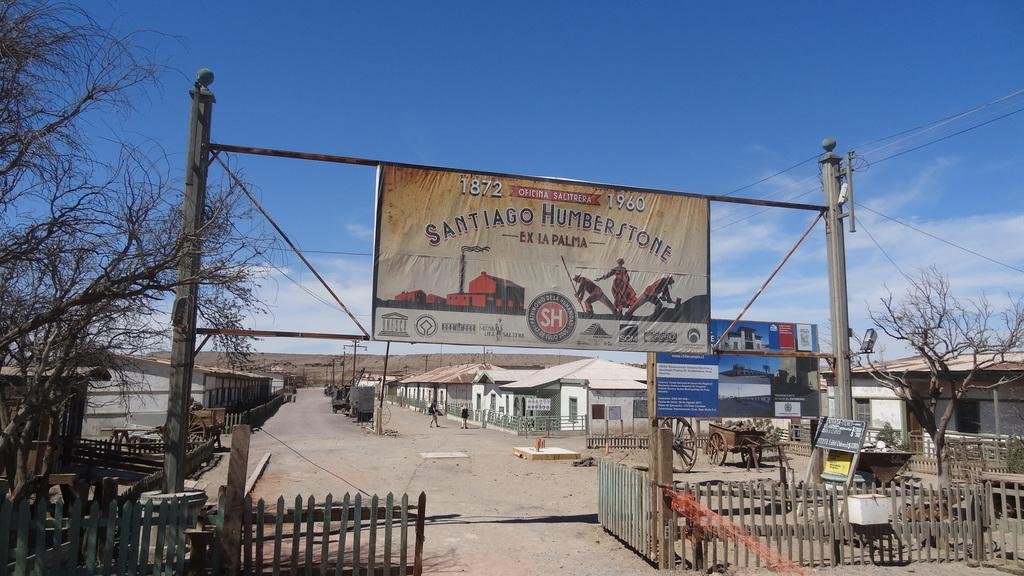<image>
Give a short and clear explanation of the subsequent image. the word santiago is on a sign outside 